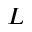<formula> <loc_0><loc_0><loc_500><loc_500>L</formula> 